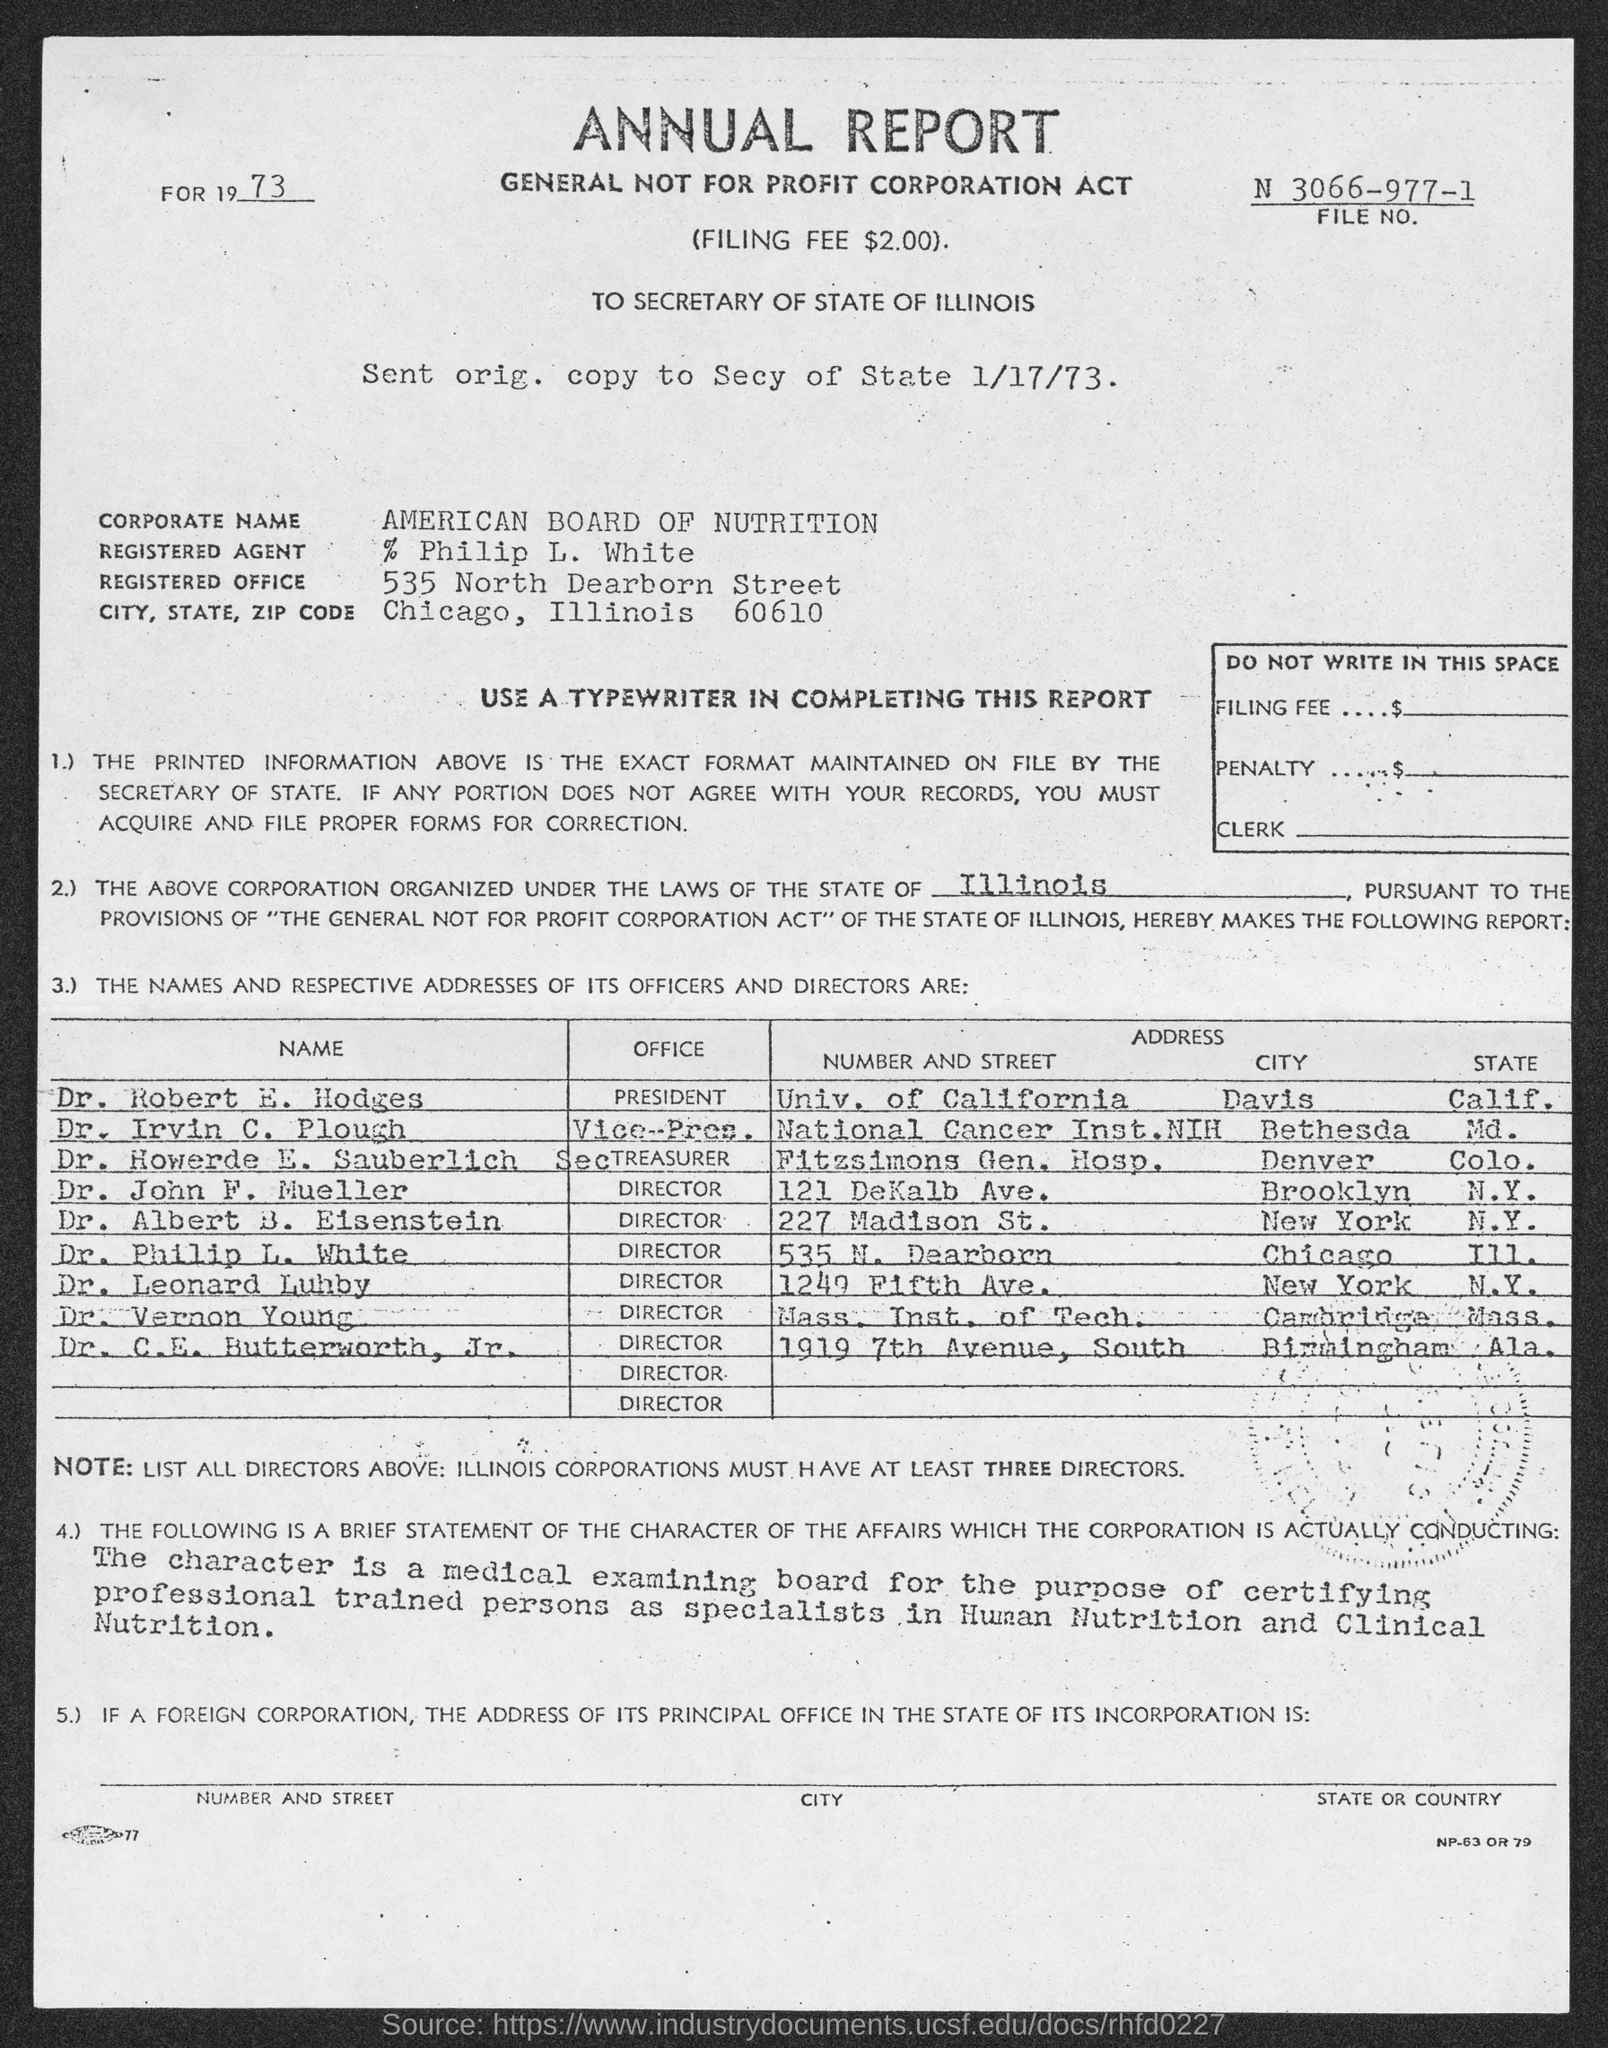Identify some key points in this picture. The registered agent named Philip L. White is mentioned in the document. The document mentions a file number: N 3066-977-1. The American Board of Nutrition is mentioned in the document. The Vice-President of the National Cancer Institute at the National Institutes of Health is Dr. Irvin C. Plough. The document provides the information of a city, state, and zipcode. The city is Chicago, the state is Illinois, and the zipcode is 60610. 